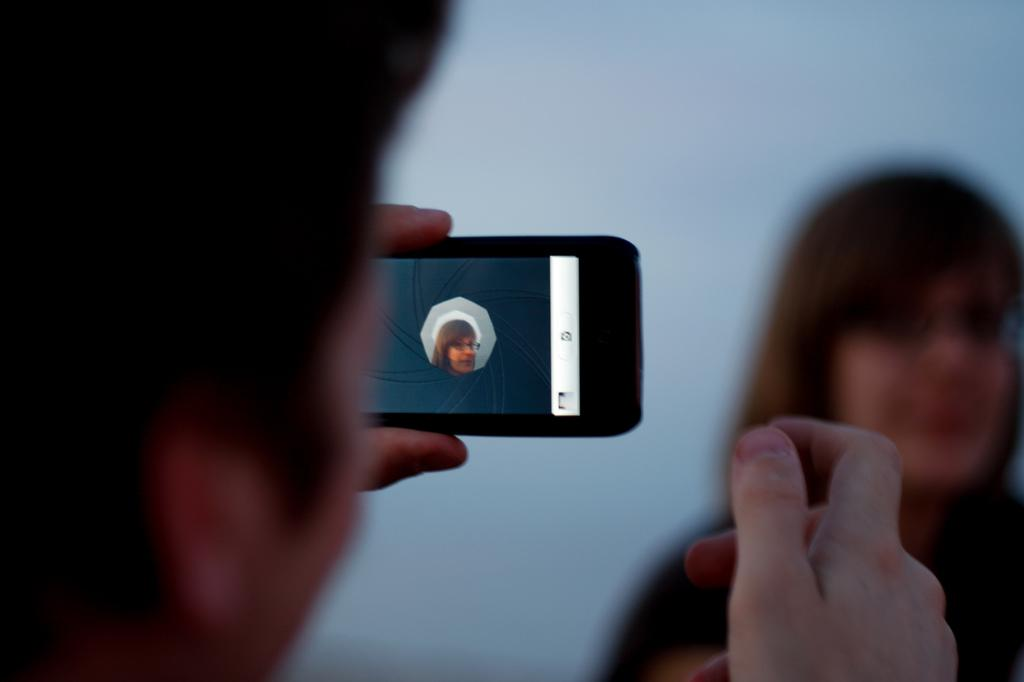What is the person on the left side of the image doing? The person is holding a mobile on the left side of the image. Who is the person capturing in the image? The person is capturing a woman in the image. What can be observed about the woman's appearance? The woman is wearing spectacles. How would you describe the background of the image? The background of the image is blurred. Who is the owner of the finger seen in the image? There is no finger visible in the image. In which direction is the woman facing in the image? The direction the woman is facing cannot be determined from the image. 